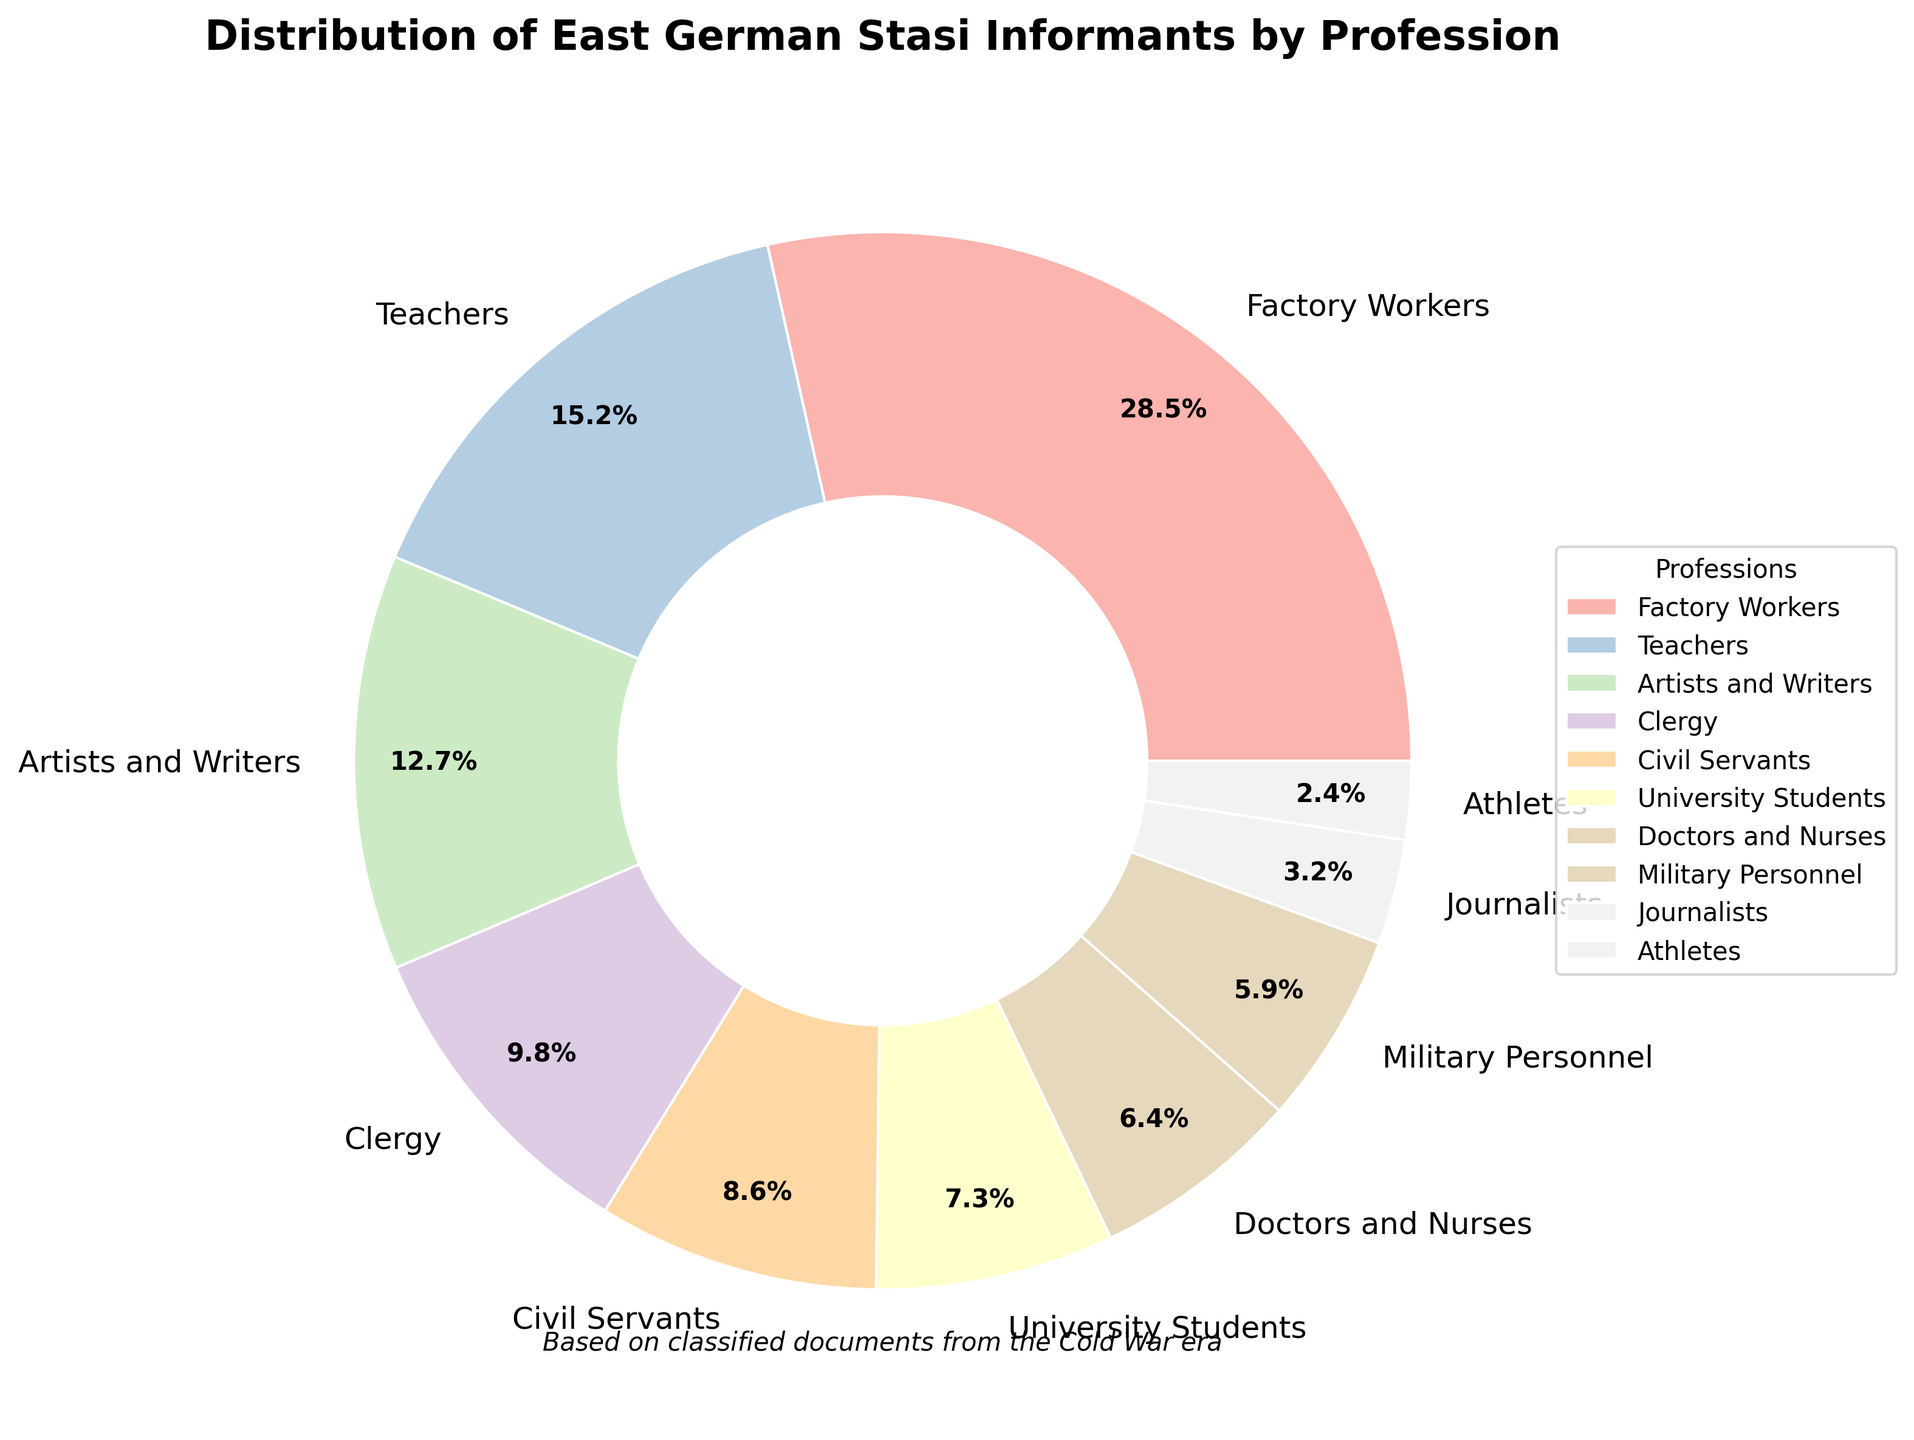Which profession has the largest percentage of Stasi informants? The figure shows different professions and their respective percentages. The profession with the largest percentage will have the largest wedge in the pie chart.
Answer: Factory Workers What is the combined percentage of Stasi informants among teachers and doctors/nurses? Locate the wedges labeled 'Teachers' and 'Doctors and Nurses'. Add their percentages: 15.2% (Teachers) + 6.4% (Doctors and Nurses) = 21.6%.
Answer: 21.6% Which two professions have the smallest and largest percentages of Stasi informants respectively? Identify the wedges with the smallest and largest sections in the pie chart. The smallest is marked by 'Athletes' and the largest by 'Factory Workers'.
Answer: Athletes and Factory Workers Is the percentage of Stasi informants who were university students greater than the percentage of civil servants? Compare the wedges labeled 'University Students' and 'Civil Servants'. University Students have 7.3% while Civil Servants have 8.6%. Since 7.3% is less than 8.6%, University Students have a smaller percentage.
Answer: No What is the percentage difference between clergy and military personnel? Look at the wedges for 'Clergy' and 'Military Personnel'. The percentages are 9.8% and 5.9%, respectively. The difference is calculated as 9.8% - 5.9% = 3.9%.
Answer: 3.9% How do the percentages of Stasi informants among artists/writers and journalists compare? Compare the wedges for 'Artists and Writers' and 'Journalists'. Artists and Writers are at 12.7%, while Journalists are at 3.2%. Therefore, Artists and Writers have a higher percentage.
Answer: Artists and Writers have a higher percentage Which profession has a percentage closest to the average percentage across all professions listed? First, calculate the average: (28.5 + 15.2 + 12.7 + 9.8 + 8.6 + 7.3 + 6.4 + 5.9 + 3.2 + 2.4) / 10 = 10%. Then, compare each profession's percentage to this average. Civil Servants are closest with 8.6%.
Answer: Civil Servants What is the total percentage of Stasi informants among factory workers, clergy, and military personnel? Sum the percentages of Factory Workers (28.5%), Clergy (9.8%), and Military Personnel (5.9%): 28.5% + 9.8% + 5.9% = 44.2%.
Answer: 44.2% Which profession has a percentage of Stasi informants that is less than 10% but more than 5%? Examine each wedge to identify percentages that fall within the range 5% to 10%. Doctors and Nurses at 6.4% and Military Personnel at 5.9% meet this criterion.
Answer: Doctors and Nurses, Military Personnel 